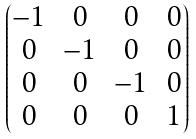<formula> <loc_0><loc_0><loc_500><loc_500>\begin{pmatrix} - 1 & 0 & 0 & 0 \\ 0 & - 1 & 0 & 0 \\ 0 & 0 & - 1 & 0 \\ 0 & 0 & 0 & 1 \end{pmatrix}</formula> 